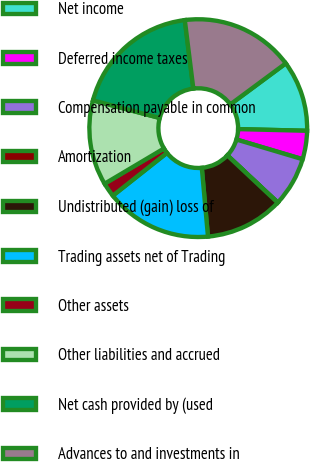<chart> <loc_0><loc_0><loc_500><loc_500><pie_chart><fcel>Net income<fcel>Deferred income taxes<fcel>Compensation payable in common<fcel>Amortization<fcel>Undistributed (gain) loss of<fcel>Trading assets net of Trading<fcel>Other assets<fcel>Other liabilities and accrued<fcel>Net cash provided by (used<fcel>Advances to and investments in<nl><fcel>10.53%<fcel>4.22%<fcel>7.37%<fcel>0.02%<fcel>11.58%<fcel>15.78%<fcel>2.12%<fcel>12.63%<fcel>18.93%<fcel>16.83%<nl></chart> 